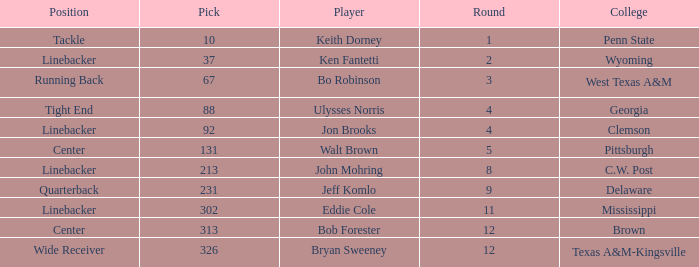What is the college pick for 213? C.W. Post. 